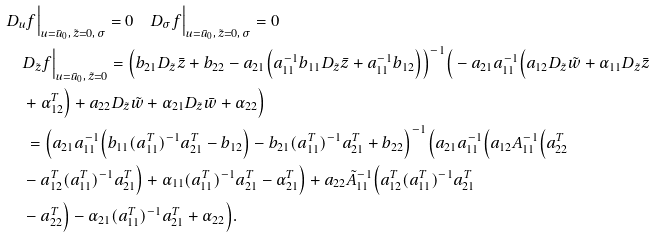<formula> <loc_0><loc_0><loc_500><loc_500>& D _ { u } f \Big | _ { u = \bar { u } _ { 0 } , \, \tilde { z } = 0 , \, \sigma } = 0 \quad D _ { \sigma } f \Big | _ { u = \bar { u } _ { 0 } , \, \tilde { z } = 0 , \, \sigma } = 0 \\ & \quad D _ { \tilde { z } } f \Big | _ { u = \bar { u } _ { 0 } , \, \tilde { z } = 0 } = \Big ( b _ { 2 1 } D _ { \tilde { z } } \bar { z } + b _ { 2 2 } - a _ { 2 1 } \Big ( a _ { 1 1 } ^ { - 1 } b _ { 1 1 } D _ { \tilde { z } } \bar { z } + a _ { 1 1 } ^ { - 1 } b _ { 1 2 } \Big ) \Big ) ^ { - 1 } \Big ( - a _ { 2 1 } a _ { 1 1 } ^ { - 1 } \Big ( a _ { 1 2 } D _ { \tilde { z } } \tilde { w } + \alpha _ { 1 1 } D _ { \tilde { z } } \bar { z } \\ & \quad + \alpha _ { 1 2 } ^ { T } \Big ) + a _ { 2 2 } D _ { \tilde { z } } \tilde { w } + \alpha _ { 2 1 } D _ { \tilde { z } } \bar { w } + \alpha _ { 2 2 } \Big ) \\ & \, \quad = \Big ( a _ { 2 1 } a _ { 1 1 } ^ { - 1 } \Big ( b _ { 1 1 } ( a _ { 1 1 } ^ { T } ) ^ { - 1 } a _ { 2 1 } ^ { T } - b _ { 1 2 } \Big ) - b _ { 2 1 } ( a _ { 1 1 } ^ { T } ) ^ { - 1 } a _ { 2 1 } ^ { T } + b _ { 2 2 } \Big ) ^ { - 1 } \Big ( a _ { 2 1 } a _ { 1 1 } ^ { - 1 } \Big ( a _ { 1 2 } A _ { 1 1 } ^ { - 1 } \Big ( a _ { 2 2 } ^ { T } \\ & \quad - a _ { 1 2 } ^ { T } ( a _ { 1 1 } ^ { T } ) ^ { - 1 } a _ { 2 1 } ^ { T } \Big ) + \alpha _ { 1 1 } ( a _ { 1 1 } ^ { T } ) ^ { - 1 } a _ { 2 1 } ^ { T } - \alpha _ { 2 1 } ^ { T } \Big ) + a _ { 2 2 } \tilde { A } _ { 1 1 } ^ { - 1 } \Big ( a _ { 1 2 } ^ { T } ( a _ { 1 1 } ^ { T } ) ^ { - 1 } a _ { 2 1 } ^ { T } \\ & \quad - a _ { 2 2 } ^ { T } \Big ) - \alpha _ { 2 1 } ( a _ { 1 1 } ^ { T } ) ^ { - 1 } a _ { 2 1 } ^ { T } + \alpha _ { 2 2 } \Big ) . \\</formula> 